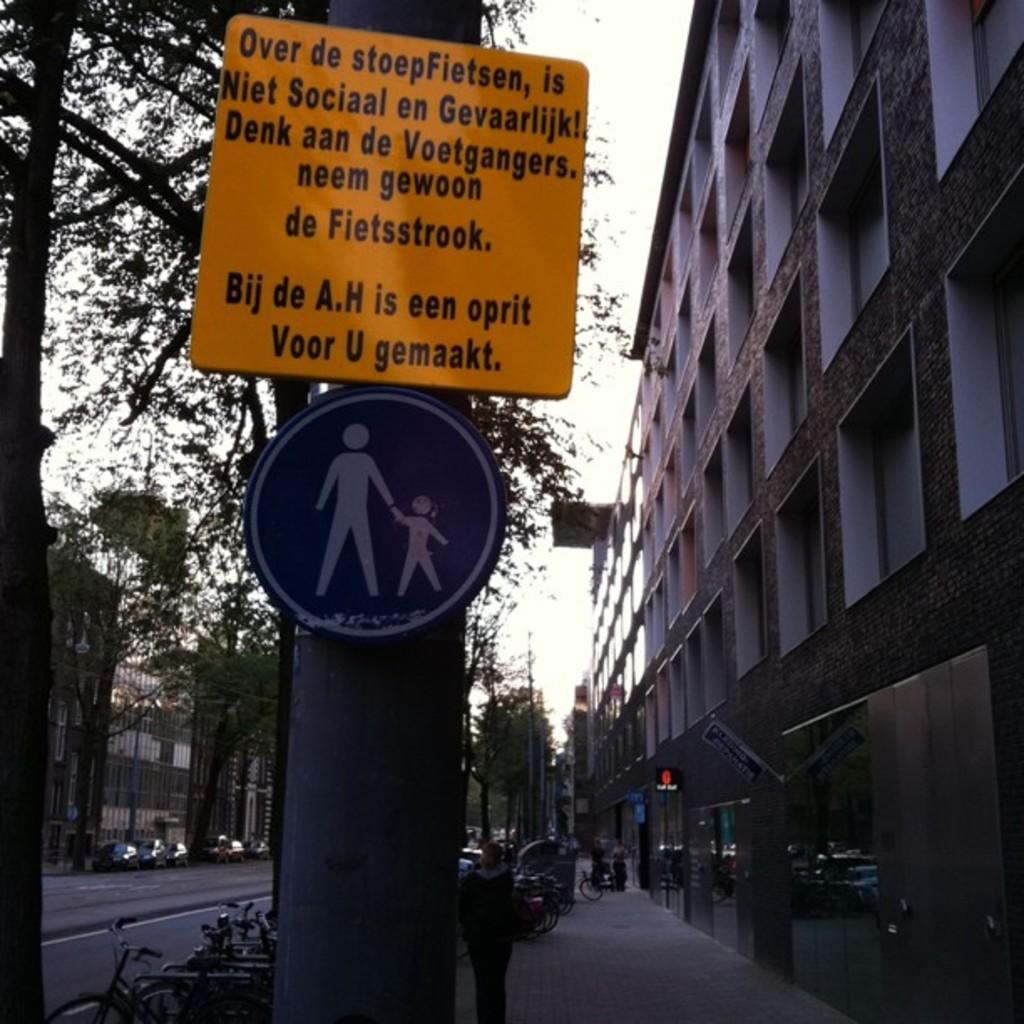<image>
Give a short and clear explanation of the subsequent image. a sign on the side of the street says Over de stoepFietson..... 